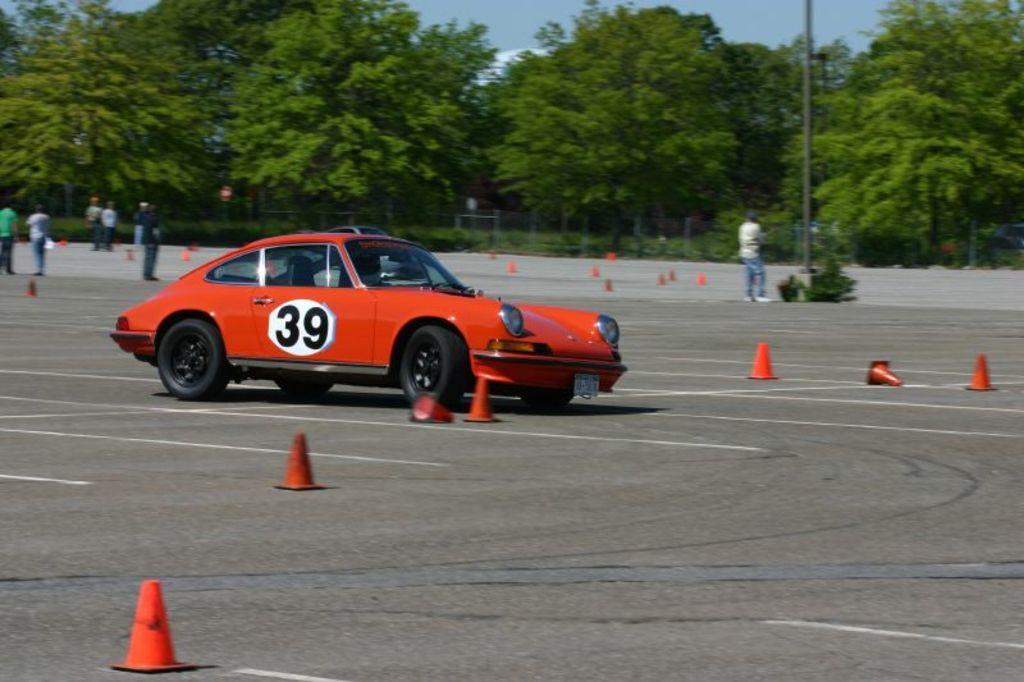Can you describe this image briefly? In this picture we can see a car and few cones on the road, in the background we can find few people, trees and a pole. 